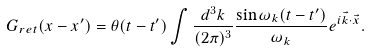Convert formula to latex. <formula><loc_0><loc_0><loc_500><loc_500>G _ { r e t } ( x - x ^ { \prime } ) = \theta ( t - t ^ { \prime } ) \int \frac { d ^ { 3 } { k } } { ( 2 \pi ) ^ { 3 } } \frac { \sin \omega _ { k } ( t - t ^ { \prime } ) } { \omega _ { k } } e ^ { i { \vec { k } } \cdot { \vec { x } } } .</formula> 